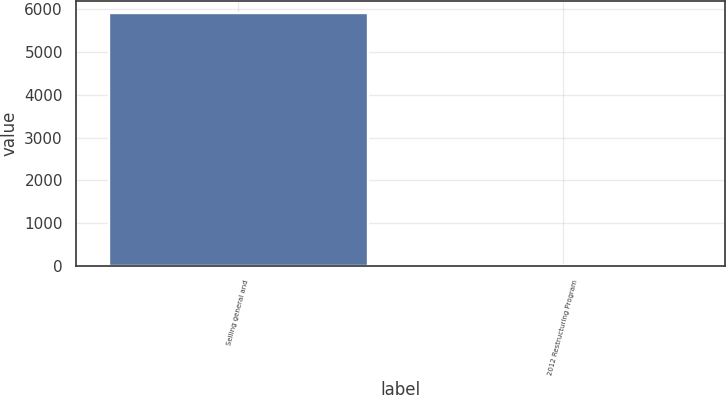<chart> <loc_0><loc_0><loc_500><loc_500><bar_chart><fcel>Selling general and<fcel>2012 Restructuring Program<nl><fcel>5910<fcel>6<nl></chart> 